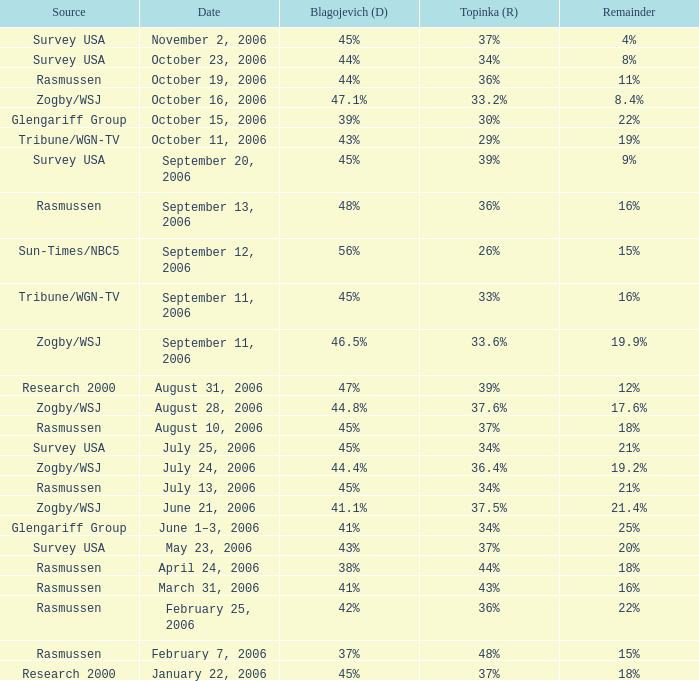Which Date has a Remainder of 20%? May 23, 2006. 